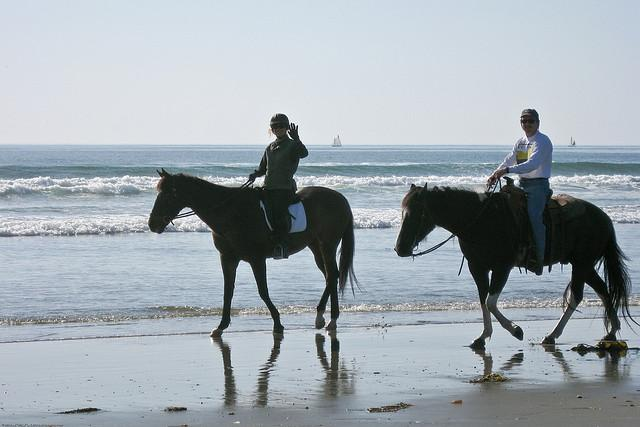Where do the riders here ride their horses? Please explain your reasoning. sea shore. The picture contains waves and sandy terrain. 